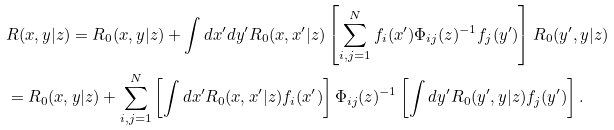Convert formula to latex. <formula><loc_0><loc_0><loc_500><loc_500>& R ( x , y | z ) = R _ { 0 } ( x , y | z ) + \int d x ^ { \prime } d y ^ { \prime } R _ { 0 } ( x , x ^ { \prime } | z ) \left [ \sum _ { i , j = 1 } ^ { N } f _ { i } ( x ^ { \prime } ) \Phi _ { i j } ( z ) ^ { - 1 } f _ { j } ( y ^ { \prime } ) \right ] R _ { 0 } ( y ^ { \prime } , y | z ) \\ & = R _ { 0 } ( x , y | z ) + \sum _ { i , j = 1 } ^ { N } \left [ \int d x ^ { \prime } R _ { 0 } ( x , x ^ { \prime } | z ) f _ { i } ( x ^ { \prime } ) \right ] \Phi _ { i j } ( z ) ^ { - 1 } \left [ \int d y ^ { \prime } R _ { 0 } ( y ^ { \prime } , y | z ) f _ { j } ( y ^ { \prime } ) \right ] .</formula> 